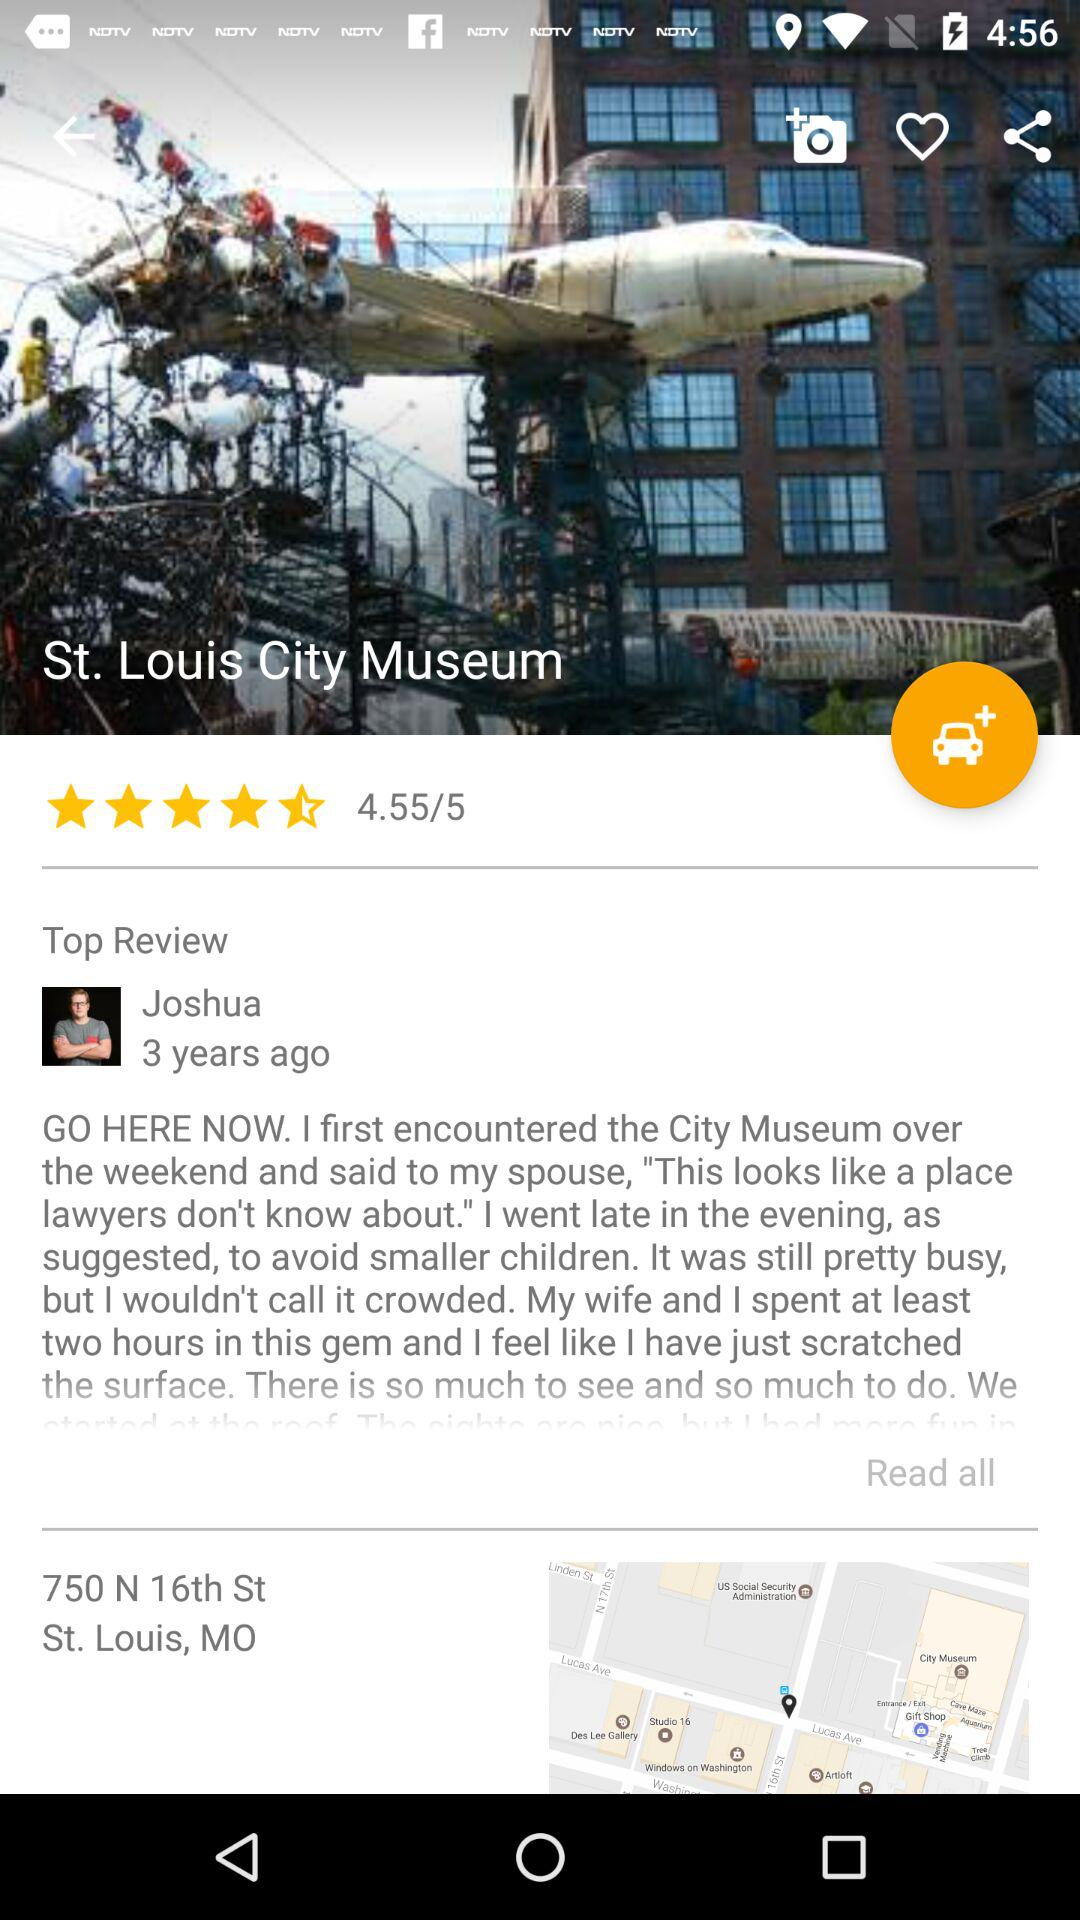How many years ago was the review posted? The review was posted 3 years ago. 